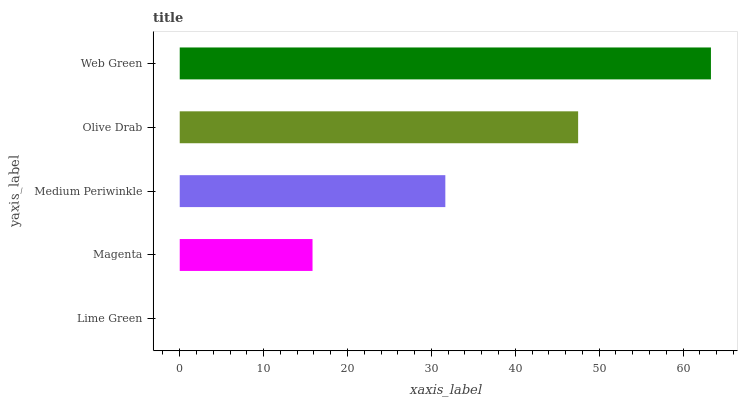Is Lime Green the minimum?
Answer yes or no. Yes. Is Web Green the maximum?
Answer yes or no. Yes. Is Magenta the minimum?
Answer yes or no. No. Is Magenta the maximum?
Answer yes or no. No. Is Magenta greater than Lime Green?
Answer yes or no. Yes. Is Lime Green less than Magenta?
Answer yes or no. Yes. Is Lime Green greater than Magenta?
Answer yes or no. No. Is Magenta less than Lime Green?
Answer yes or no. No. Is Medium Periwinkle the high median?
Answer yes or no. Yes. Is Medium Periwinkle the low median?
Answer yes or no. Yes. Is Magenta the high median?
Answer yes or no. No. Is Olive Drab the low median?
Answer yes or no. No. 